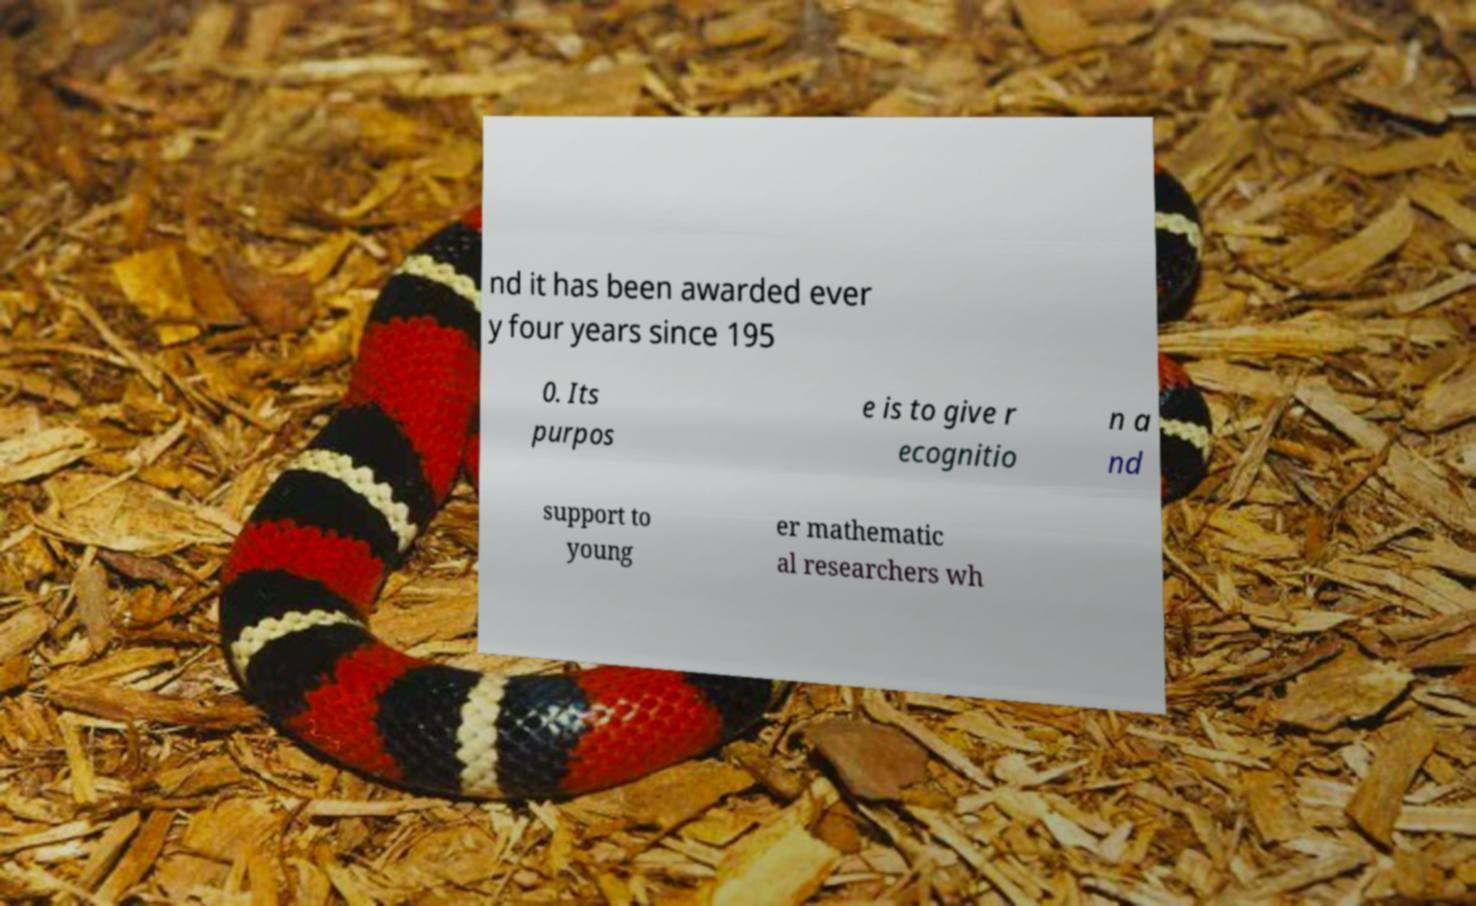I need the written content from this picture converted into text. Can you do that? nd it has been awarded ever y four years since 195 0. Its purpos e is to give r ecognitio n a nd support to young er mathematic al researchers wh 